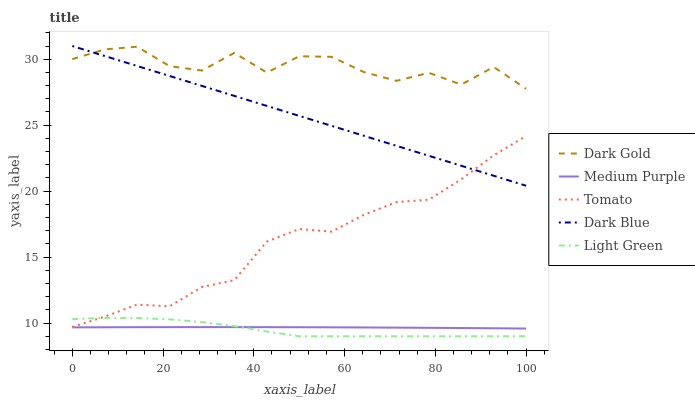Does Light Green have the minimum area under the curve?
Answer yes or no. Yes. Does Dark Gold have the maximum area under the curve?
Answer yes or no. Yes. Does Tomato have the minimum area under the curve?
Answer yes or no. No. Does Tomato have the maximum area under the curve?
Answer yes or no. No. Is Dark Blue the smoothest?
Answer yes or no. Yes. Is Dark Gold the roughest?
Answer yes or no. Yes. Is Tomato the smoothest?
Answer yes or no. No. Is Tomato the roughest?
Answer yes or no. No. Does Tomato have the lowest value?
Answer yes or no. No. Does Dark Blue have the highest value?
Answer yes or no. Yes. Does Tomato have the highest value?
Answer yes or no. No. Is Medium Purple less than Dark Gold?
Answer yes or no. Yes. Is Dark Blue greater than Light Green?
Answer yes or no. Yes. Does Medium Purple intersect Light Green?
Answer yes or no. Yes. Is Medium Purple less than Light Green?
Answer yes or no. No. Is Medium Purple greater than Light Green?
Answer yes or no. No. Does Medium Purple intersect Dark Gold?
Answer yes or no. No. 